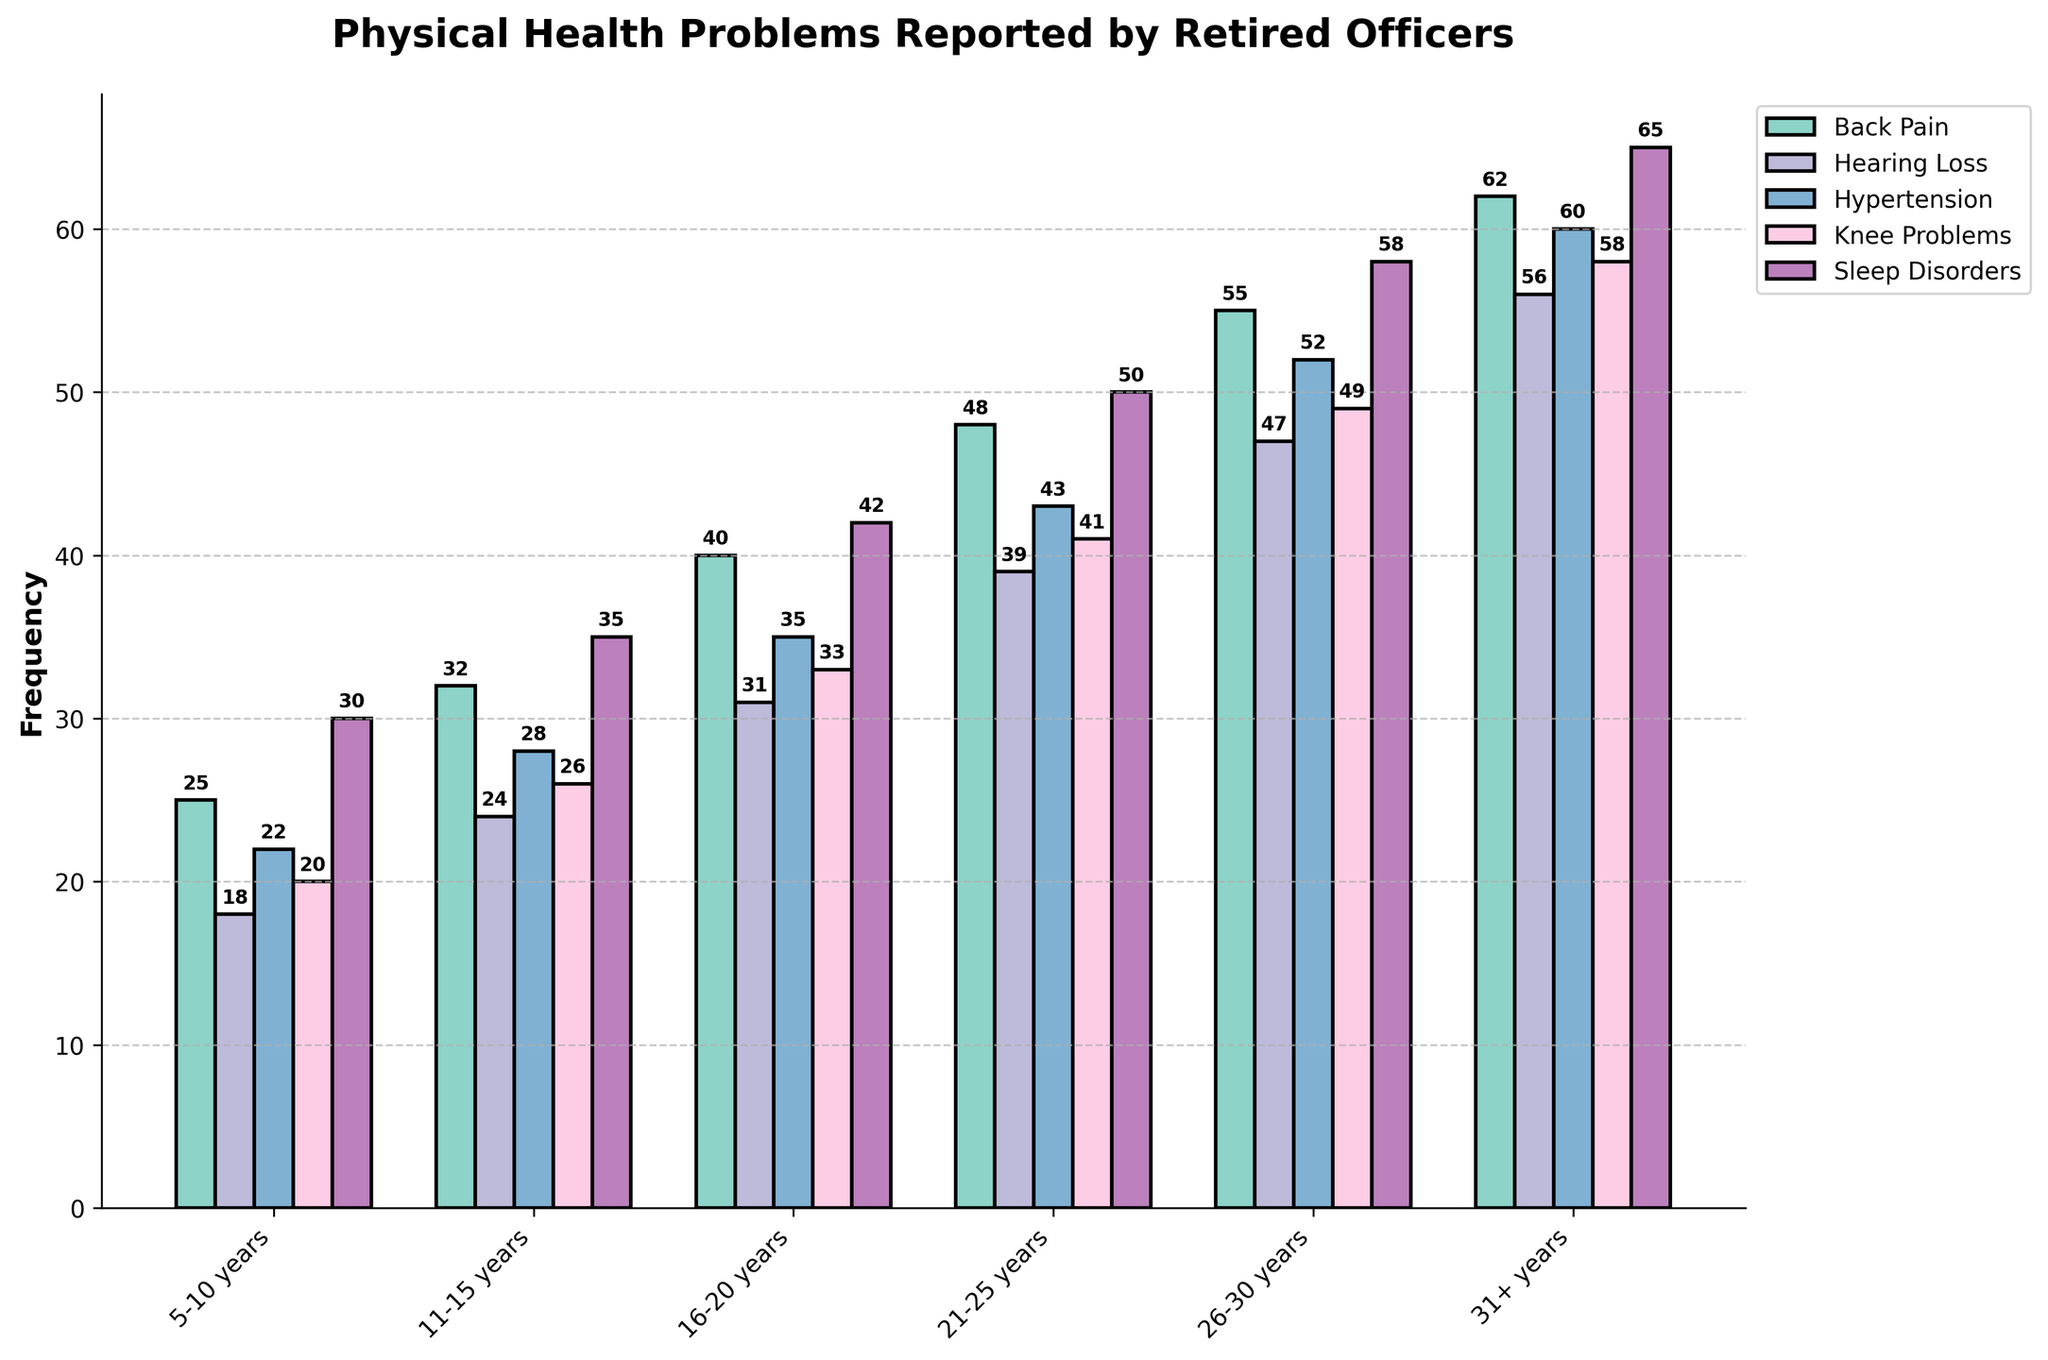What is the most frequently reported health problem among officers with 31+ years of service? The bar representing 'Sleep Disorders' for officers with 31+ years of service is the tallest, indicating that it has the highest frequency.
Answer: Sleep Disorders How does the frequency of back pain compare between officers with 5-10 years and 26-30 years of service? The bar for 'Back Pain' shows 25 for 5-10 years and 55 for 26-30 years. Subtracting 25 from 55 gives 30.
Answer: 30 more for 26-30 years What is the average frequency of knee problems reported by officers across all years of service? Summing up the numbers for 'Knee Problems' (20+26+33+41+49+58) gives 227. Dividing by the number of categories (6) gives 227/6 = 37.83.
Answer: 37.83 Which health problem shows the smallest increase in frequency from officers with 5-10 years to 11-15 years of service? By comparing the differences (32-25, 24-18, 28-22, 26-20, 35-30), 'Sleep Disorders' has the smallest increase which is 5 (35-30).
Answer: Sleep Disorders What is the difference in reported frequency of hypertension between the groups with the least and most years of service? The 'Hypertension' frequency is 22 for the 5-10 years and 60 for the 31+ years group. Subtracting 22 from 60 gives 38.
Answer: 38 In which years-of-service group is hearing loss almost as frequent as hypertension? The bars for 'Hearing Loss' and 'Hypertension' are nearly the same height in the 31+ years group, with frequencies 56 and 60, respectively.
Answer: 31+ years What is the cumulative frequency of back pain for officers with up to 20 years of service? Adding the values for 'Back Pain' (25 + 32 + 40) for the first three categories gives 97.
Answer: 97 How much more frequent are knee problems than hearing loss for officers with 26-30 years of service? The 'Knee Problems' frequency is 49 and 'Hearing Loss' is 47 for the 26-30 years group. Subtracting 47 from 49 gives 2.
Answer: 2 What is the total frequency of health problems reported by officers with 21-25 years of service? Adding all the reported frequencies for the 21-25 years group (48 + 39 + 43 + 41 + 50) gives 221.
Answer: 221 Which health issue experiences the most significant increase from the 11-15 years group to the 16-20 years group? The differences are 40-32 for 'Back Pain' (8), 31-24 for 'Hearing Loss' (7), 35-28 for 'Hypertension' (7), 33-26 for 'Knee Problems' (7), 42-35 for 'Sleep Disorders' (7). 'Back Pain' has the largest increase by 8.
Answer: Back Pain 